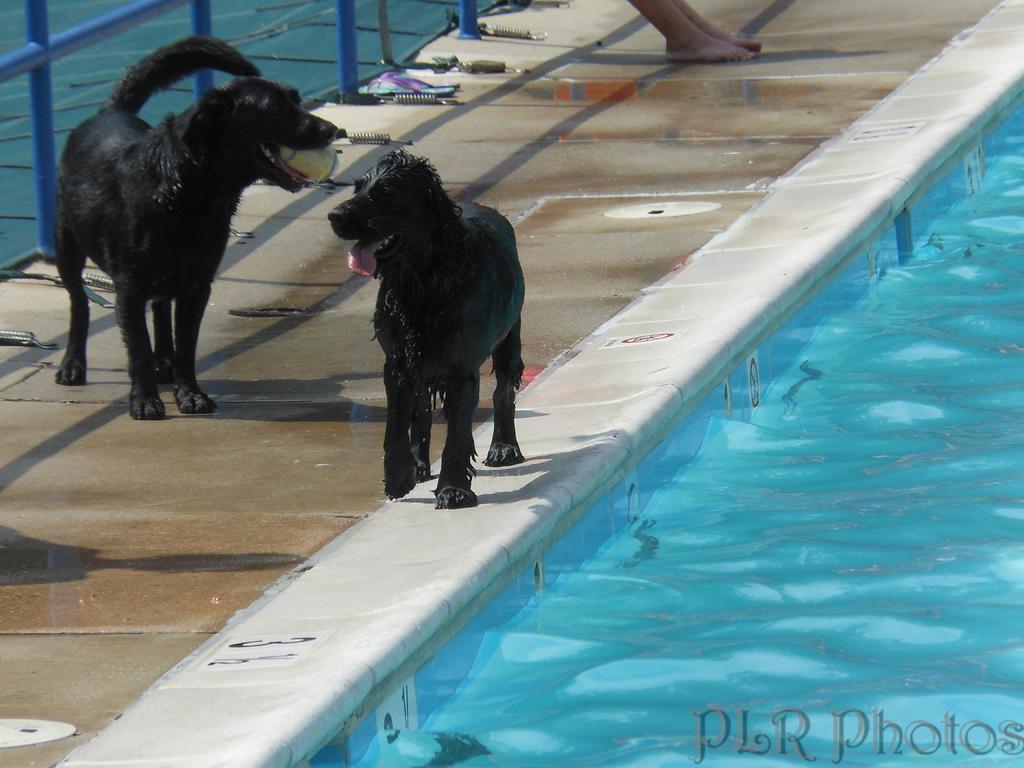Could you give a brief overview of what you see in this image? There are two black color dogs are present on the left side of this image. We can see the legs of a human at the top of this image. There is a water at the bottom of this image and in the top left corner of this image. 